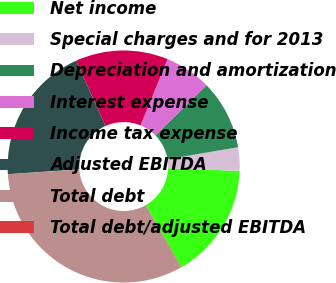Convert chart. <chart><loc_0><loc_0><loc_500><loc_500><pie_chart><fcel>Net income<fcel>Special charges and for 2013<fcel>Depreciation and amortization<fcel>Interest expense<fcel>Income tax expense<fcel>Adjusted EBITDA<fcel>Total debt<fcel>Total debt/adjusted EBITDA<nl><fcel>16.12%<fcel>3.26%<fcel>9.69%<fcel>6.47%<fcel>12.9%<fcel>19.33%<fcel>32.19%<fcel>0.04%<nl></chart> 